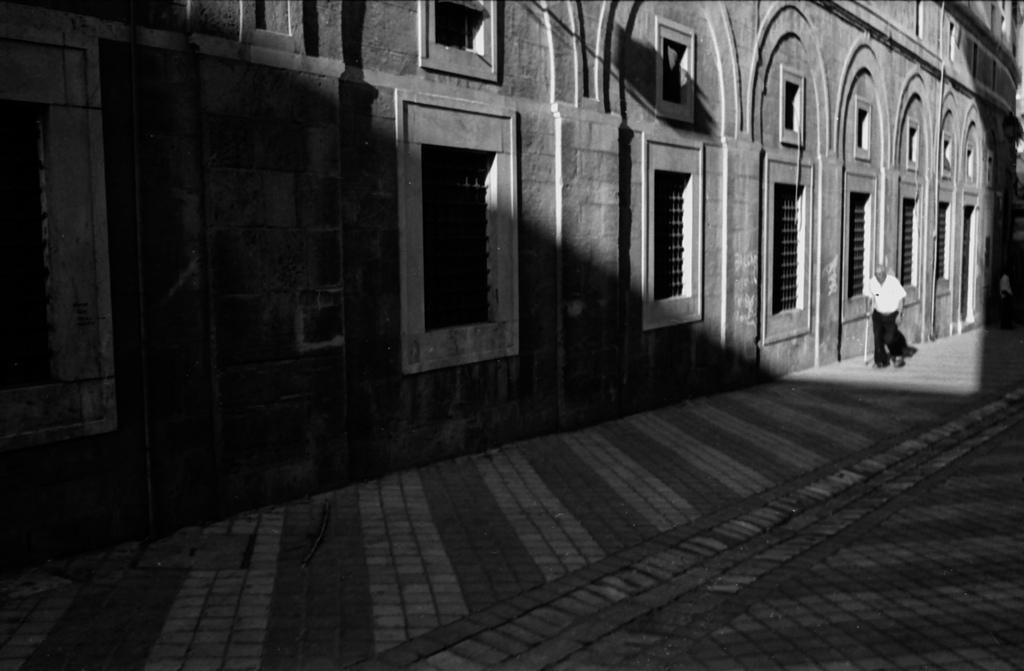Can you describe this image briefly? In this image I can see the black and white picture in which I can see the ground, a person wearing white and black colored dress is standing on the ground and a building. I can see few windows of the building and in the background I can see another person standing. 